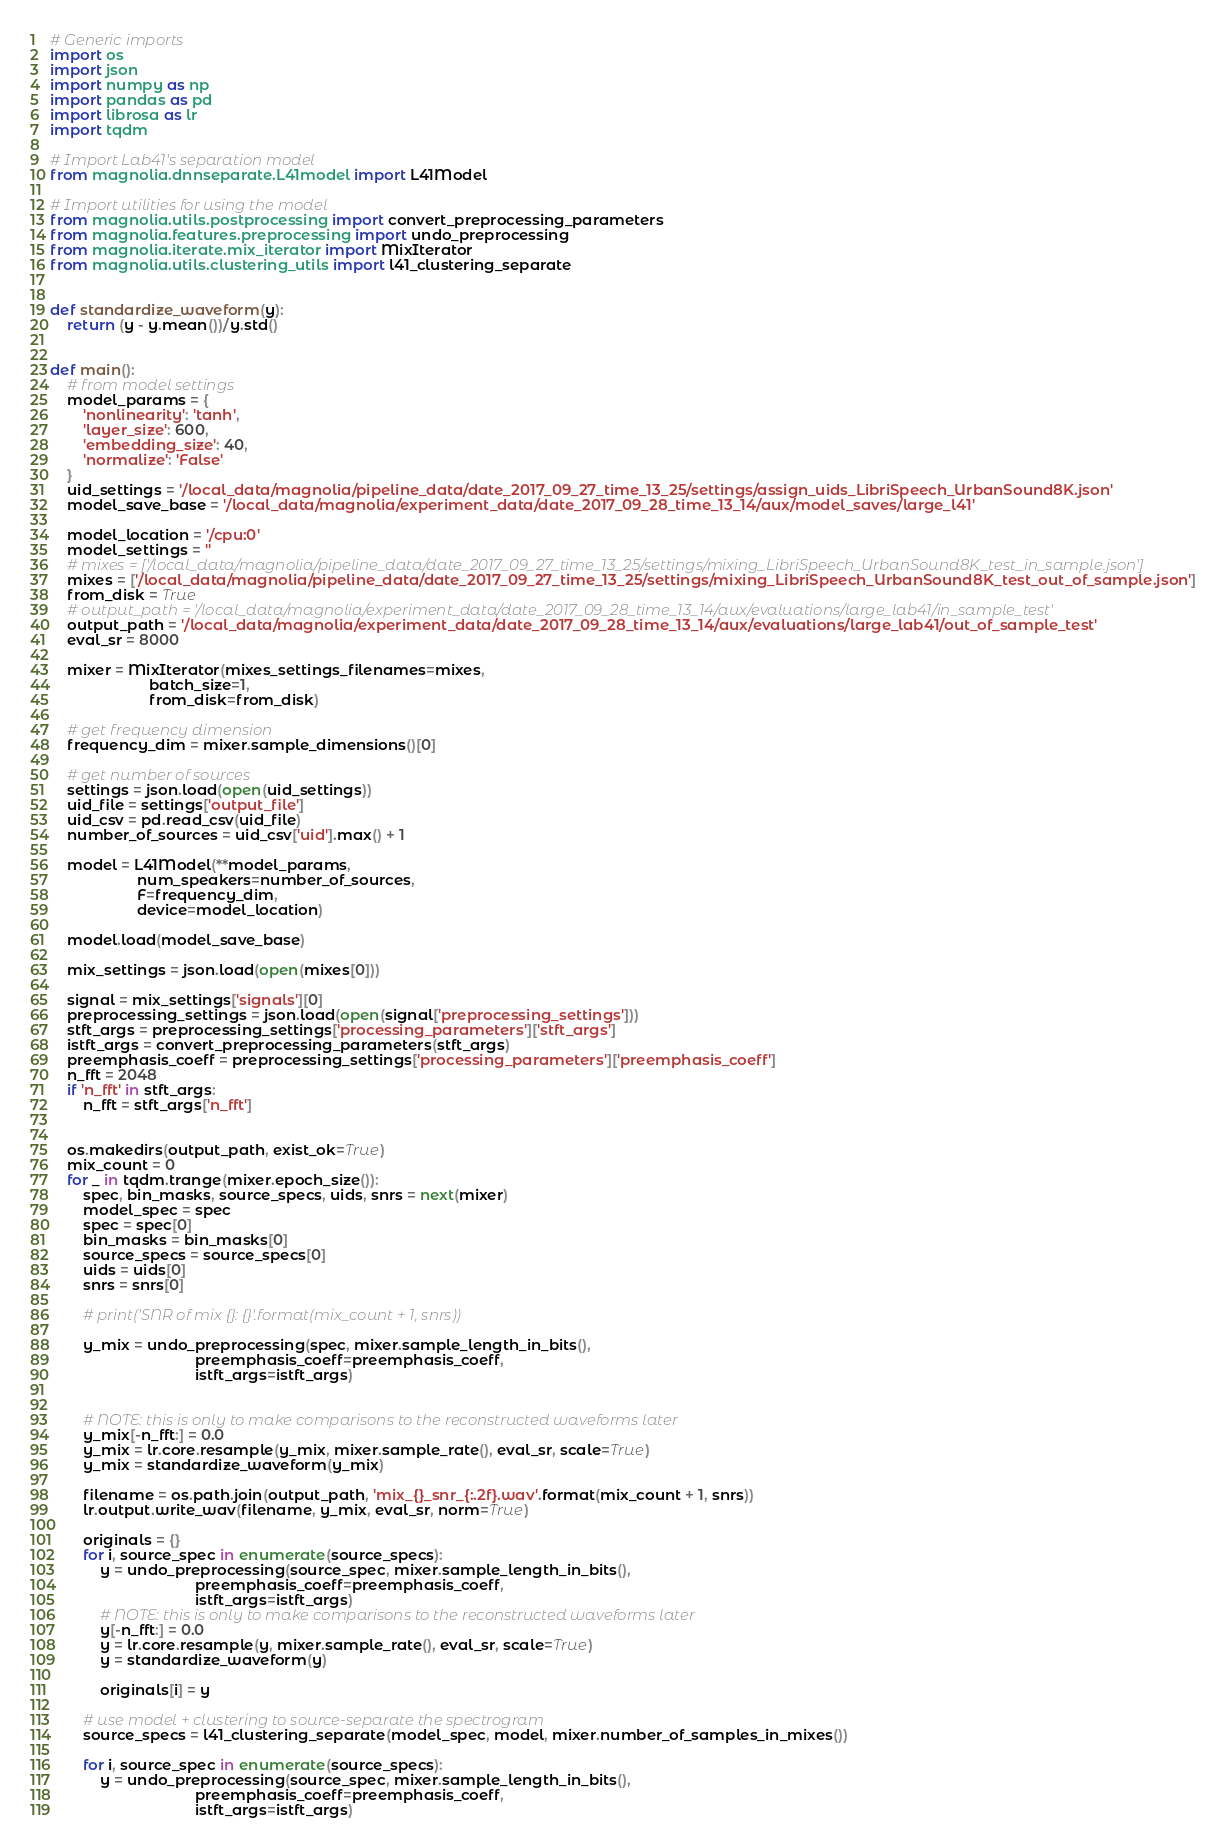Convert code to text. <code><loc_0><loc_0><loc_500><loc_500><_Python_># Generic imports
import os
import json
import numpy as np
import pandas as pd
import librosa as lr
import tqdm

# Import Lab41's separation model
from magnolia.dnnseparate.L41model import L41Model

# Import utilities for using the model
from magnolia.utils.postprocessing import convert_preprocessing_parameters
from magnolia.features.preprocessing import undo_preprocessing
from magnolia.iterate.mix_iterator import MixIterator
from magnolia.utils.clustering_utils import l41_clustering_separate


def standardize_waveform(y):
    return (y - y.mean())/y.std()


def main():
    # from model settings
    model_params = {
        'nonlinearity': 'tanh',
        'layer_size': 600,
        'embedding_size': 40,
        'normalize': 'False'
    }
    uid_settings = '/local_data/magnolia/pipeline_data/date_2017_09_27_time_13_25/settings/assign_uids_LibriSpeech_UrbanSound8K.json'
    model_save_base = '/local_data/magnolia/experiment_data/date_2017_09_28_time_13_14/aux/model_saves/large_l41'

    model_location = '/cpu:0'
    model_settings = ''
    # mixes = ['/local_data/magnolia/pipeline_data/date_2017_09_27_time_13_25/settings/mixing_LibriSpeech_UrbanSound8K_test_in_sample.json']
    mixes = ['/local_data/magnolia/pipeline_data/date_2017_09_27_time_13_25/settings/mixing_LibriSpeech_UrbanSound8K_test_out_of_sample.json']
    from_disk = True
    # output_path = '/local_data/magnolia/experiment_data/date_2017_09_28_time_13_14/aux/evaluations/large_lab41/in_sample_test'
    output_path = '/local_data/magnolia/experiment_data/date_2017_09_28_time_13_14/aux/evaluations/large_lab41/out_of_sample_test'
    eval_sr = 8000

    mixer = MixIterator(mixes_settings_filenames=mixes,
                        batch_size=1,
                        from_disk=from_disk)

    # get frequency dimension
    frequency_dim = mixer.sample_dimensions()[0]

    # get number of sources
    settings = json.load(open(uid_settings))
    uid_file = settings['output_file']
    uid_csv = pd.read_csv(uid_file)
    number_of_sources = uid_csv['uid'].max() + 1

    model = L41Model(**model_params,
                     num_speakers=number_of_sources,
                     F=frequency_dim,
                     device=model_location)

    model.load(model_save_base)

    mix_settings = json.load(open(mixes[0]))

    signal = mix_settings['signals'][0]
    preprocessing_settings = json.load(open(signal['preprocessing_settings']))
    stft_args = preprocessing_settings['processing_parameters']['stft_args']
    istft_args = convert_preprocessing_parameters(stft_args)
    preemphasis_coeff = preprocessing_settings['processing_parameters']['preemphasis_coeff']
    n_fft = 2048
    if 'n_fft' in stft_args:
        n_fft = stft_args['n_fft']


    os.makedirs(output_path, exist_ok=True)
    mix_count = 0
    for _ in tqdm.trange(mixer.epoch_size()):
        spec, bin_masks, source_specs, uids, snrs = next(mixer)
        model_spec = spec
        spec = spec[0]
        bin_masks = bin_masks[0]
        source_specs = source_specs[0]
        uids = uids[0]
        snrs = snrs[0]

        # print('SNR of mix {}: {}'.format(mix_count + 1, snrs))

        y_mix = undo_preprocessing(spec, mixer.sample_length_in_bits(),
                                   preemphasis_coeff=preemphasis_coeff,
                                   istft_args=istft_args)


        # NOTE: this is only to make comparisons to the reconstructed waveforms later
        y_mix[-n_fft:] = 0.0
        y_mix = lr.core.resample(y_mix, mixer.sample_rate(), eval_sr, scale=True)
        y_mix = standardize_waveform(y_mix)

        filename = os.path.join(output_path, 'mix_{}_snr_{:.2f}.wav'.format(mix_count + 1, snrs))
        lr.output.write_wav(filename, y_mix, eval_sr, norm=True)

        originals = {}
        for i, source_spec in enumerate(source_specs):
            y = undo_preprocessing(source_spec, mixer.sample_length_in_bits(),
                                   preemphasis_coeff=preemphasis_coeff,
                                   istft_args=istft_args)
            # NOTE: this is only to make comparisons to the reconstructed waveforms later
            y[-n_fft:] = 0.0
            y = lr.core.resample(y, mixer.sample_rate(), eval_sr, scale=True)
            y = standardize_waveform(y)

            originals[i] = y

        # use model + clustering to source-separate the spectrogram
        source_specs = l41_clustering_separate(model_spec, model, mixer.number_of_samples_in_mixes())

        for i, source_spec in enumerate(source_specs):
            y = undo_preprocessing(source_spec, mixer.sample_length_in_bits(),
                                   preemphasis_coeff=preemphasis_coeff,
                                   istft_args=istft_args)</code> 